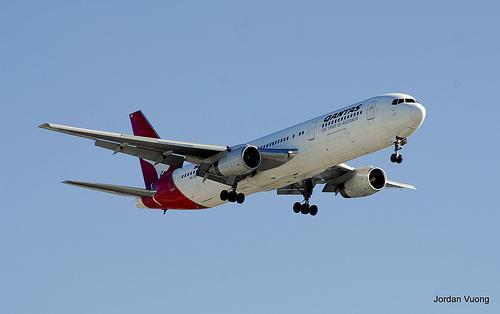How many airplanes are in the photo?
Give a very brief answer. 1. 